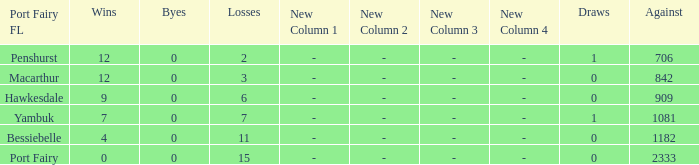How many byes when the draws are less than 0? 0.0. Could you parse the entire table? {'header': ['Port Fairy FL', 'Wins', 'Byes', 'Losses', 'New Column 1', 'New Column 2', 'New Column 3', 'New Column 4', 'Draws', 'Against'], 'rows': [['Penshurst', '12', '0', '2', '-', '-', '-', '-', '1', '706'], ['Macarthur', '12', '0', '3', '-', '-', '-', '-', '0', '842'], ['Hawkesdale', '9', '0', '6', '-', '-', '-', '-', '0', '909'], ['Yambuk', '7', '0', '7', '-', '-', '-', '-', '1', '1081'], ['Bessiebelle', '4', '0', '11', '-', '-', '-', '-', '0', '1182'], ['Port Fairy', '0', '0', '15', '-', '-', '-', '-', '0', '2333']]} 